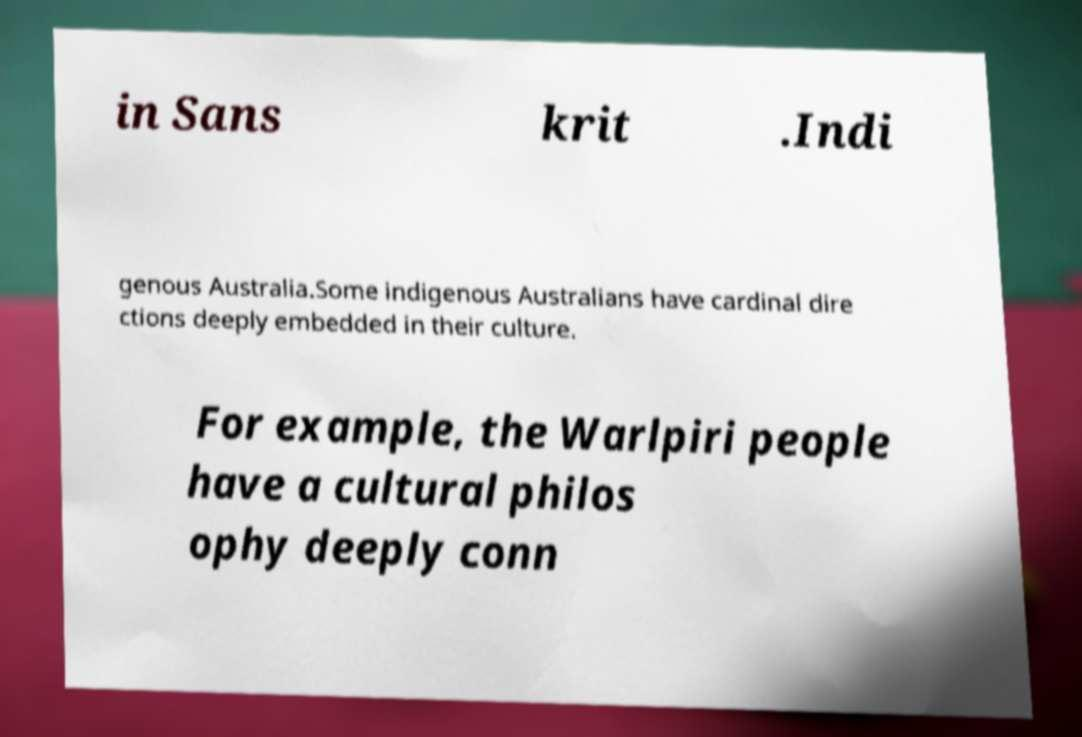Can you accurately transcribe the text from the provided image for me? in Sans krit .Indi genous Australia.Some indigenous Australians have cardinal dire ctions deeply embedded in their culture. For example, the Warlpiri people have a cultural philos ophy deeply conn 